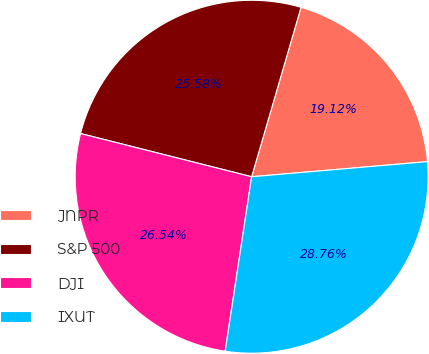Convert chart. <chart><loc_0><loc_0><loc_500><loc_500><pie_chart><fcel>JNPR<fcel>S&P 500<fcel>DJI<fcel>IXUT<nl><fcel>19.12%<fcel>25.58%<fcel>26.54%<fcel>28.76%<nl></chart> 